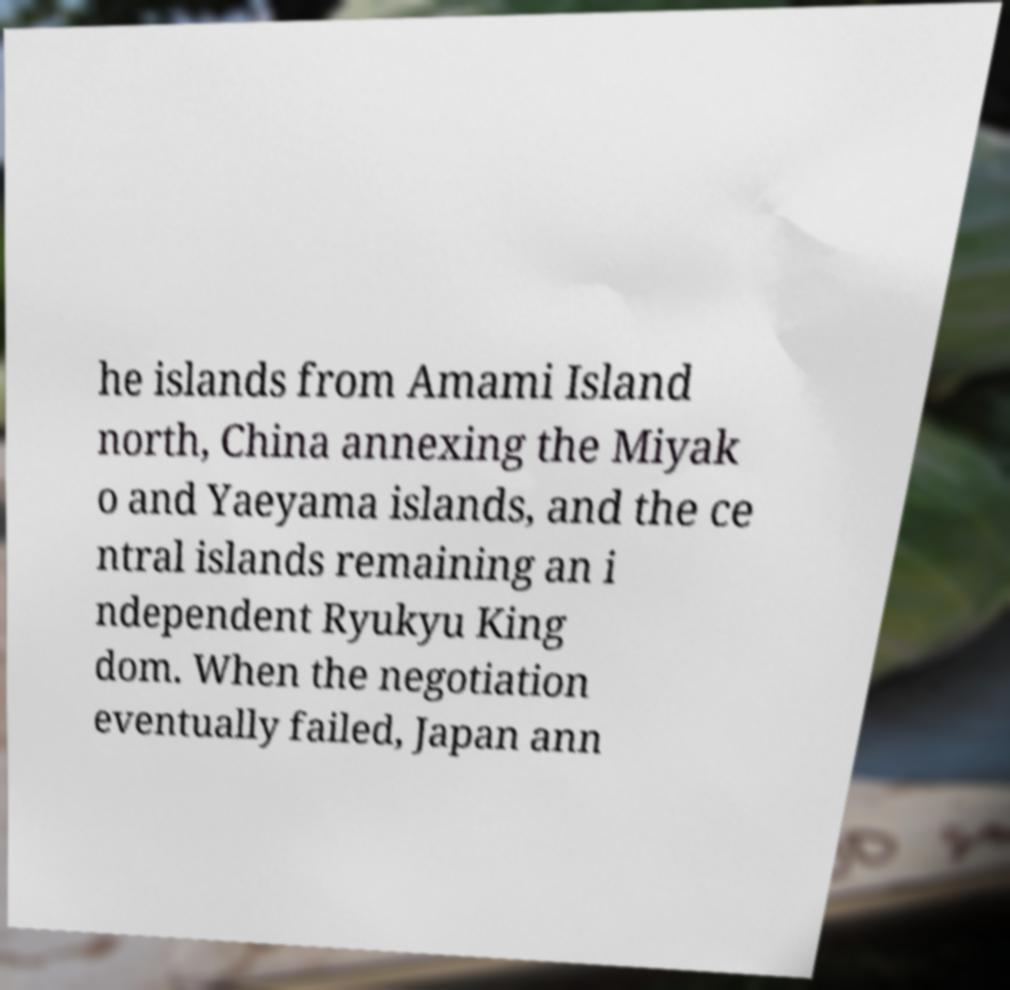For documentation purposes, I need the text within this image transcribed. Could you provide that? he islands from Amami Island north, China annexing the Miyak o and Yaeyama islands, and the ce ntral islands remaining an i ndependent Ryukyu King dom. When the negotiation eventually failed, Japan ann 